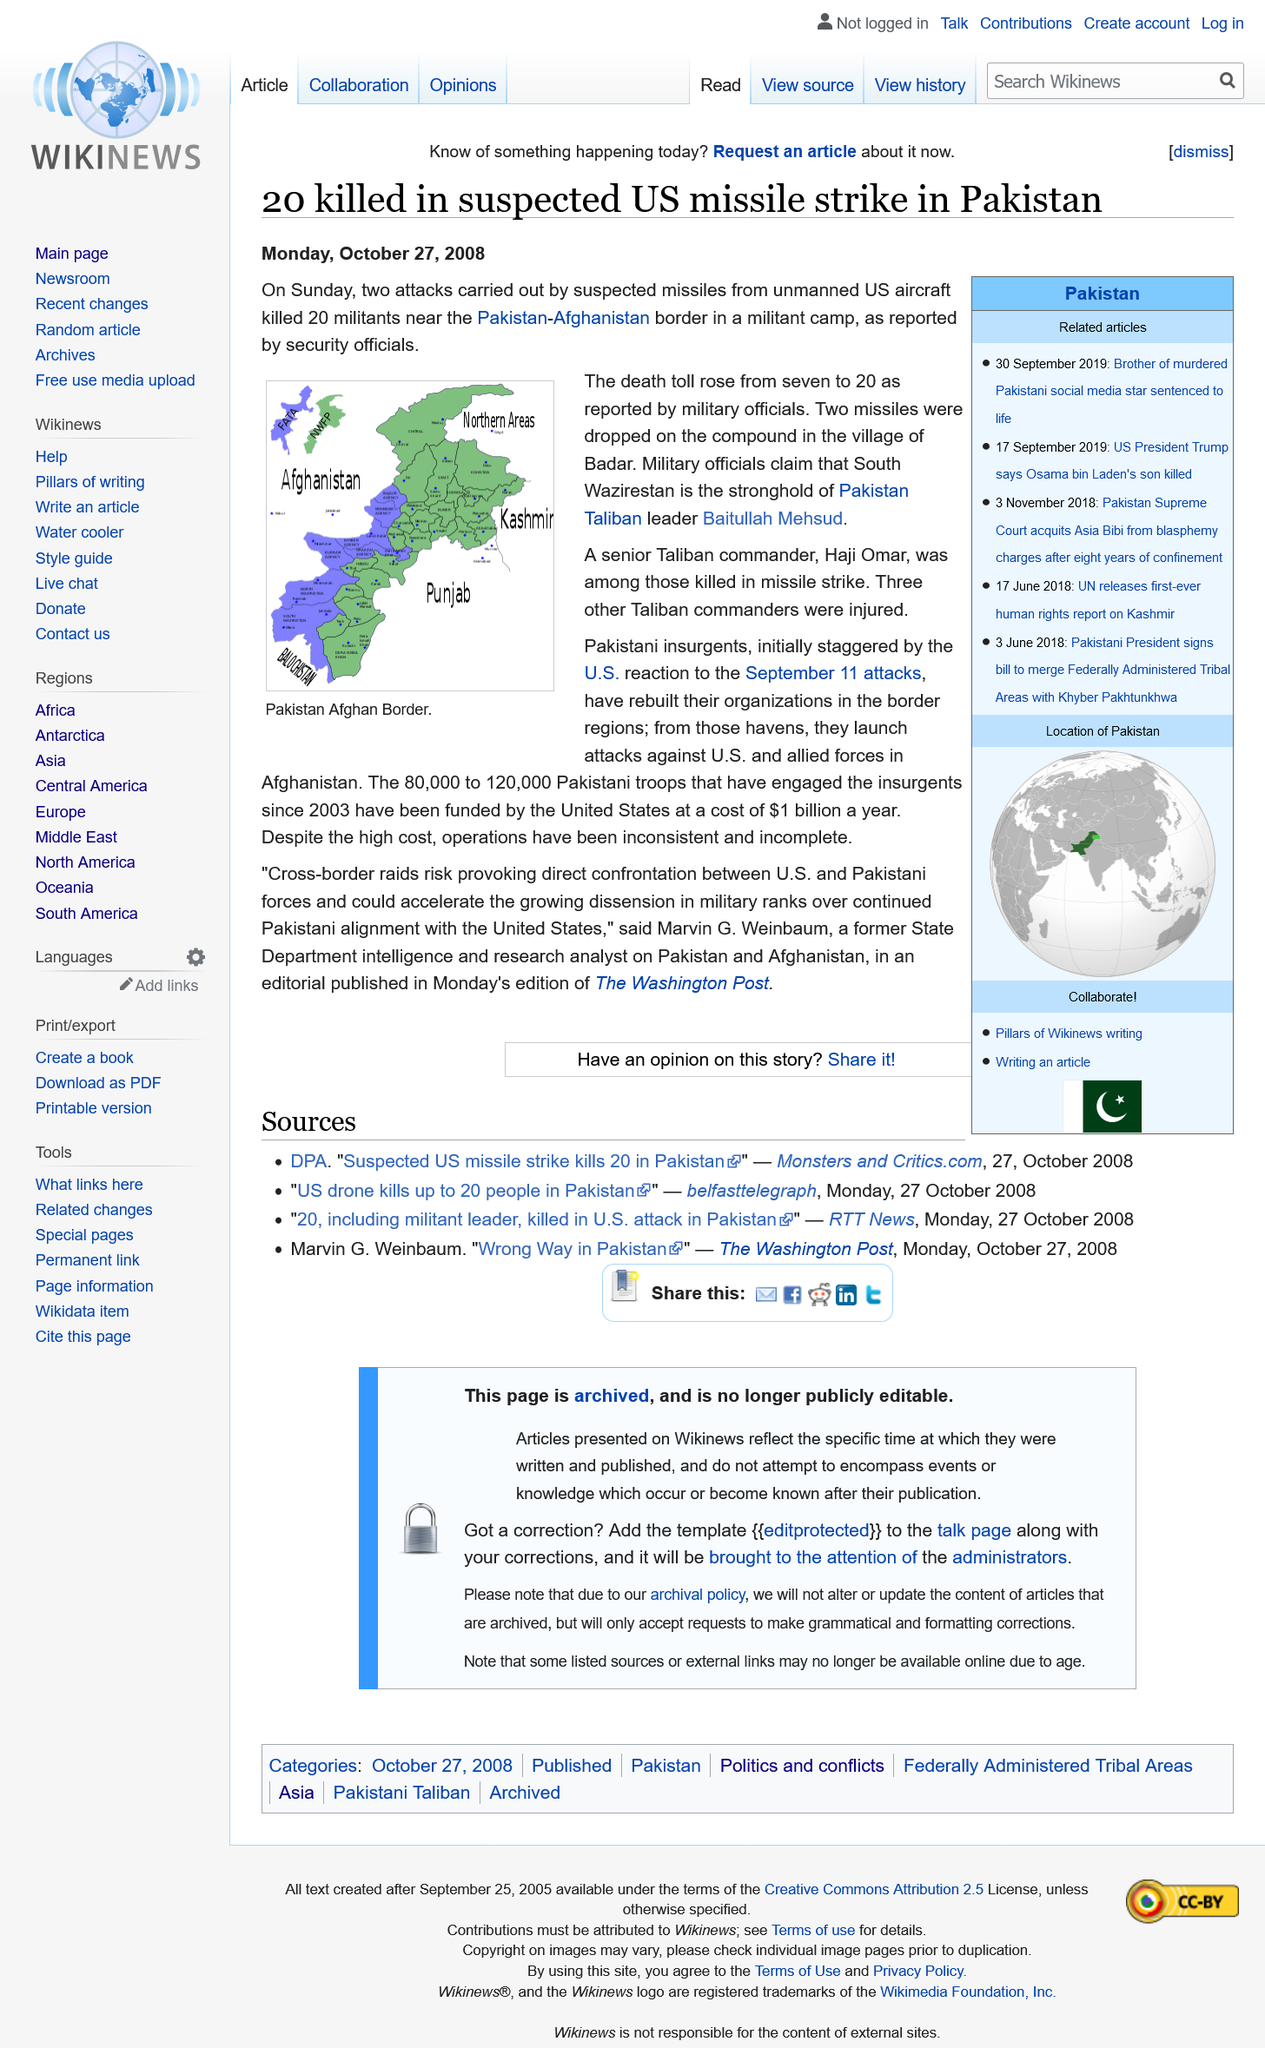Indicate a few pertinent items in this graphic. On October 27, 2008, in a suspected US missile strike, 20 people lost their lives in Pakistan. Twenty people were killed in a suspected US missile strike in Pakistan. The missile strike resulted in the death of Haji Omar, a senior Taliban commander and leader of the group, who was among those killed in the attack. 